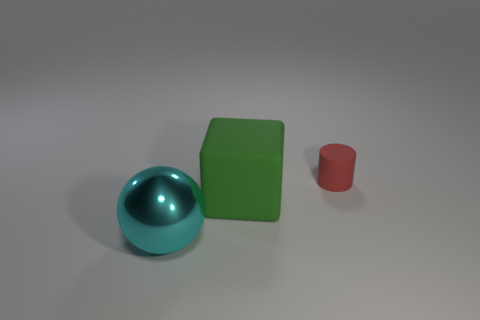Add 1 green objects. How many objects exist? 4 Subtract 1 balls. How many balls are left? 0 Subtract all spheres. How many objects are left? 2 Subtract all yellow blocks. Subtract all purple cylinders. How many blocks are left? 1 Subtract all matte blocks. Subtract all metal objects. How many objects are left? 1 Add 2 red cylinders. How many red cylinders are left? 3 Add 3 gray shiny spheres. How many gray shiny spheres exist? 3 Subtract 0 brown cylinders. How many objects are left? 3 